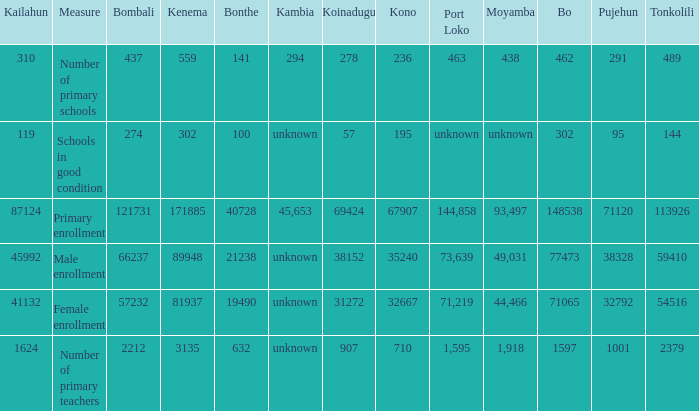What is the lowest number associated with Tonkolili? 144.0. 